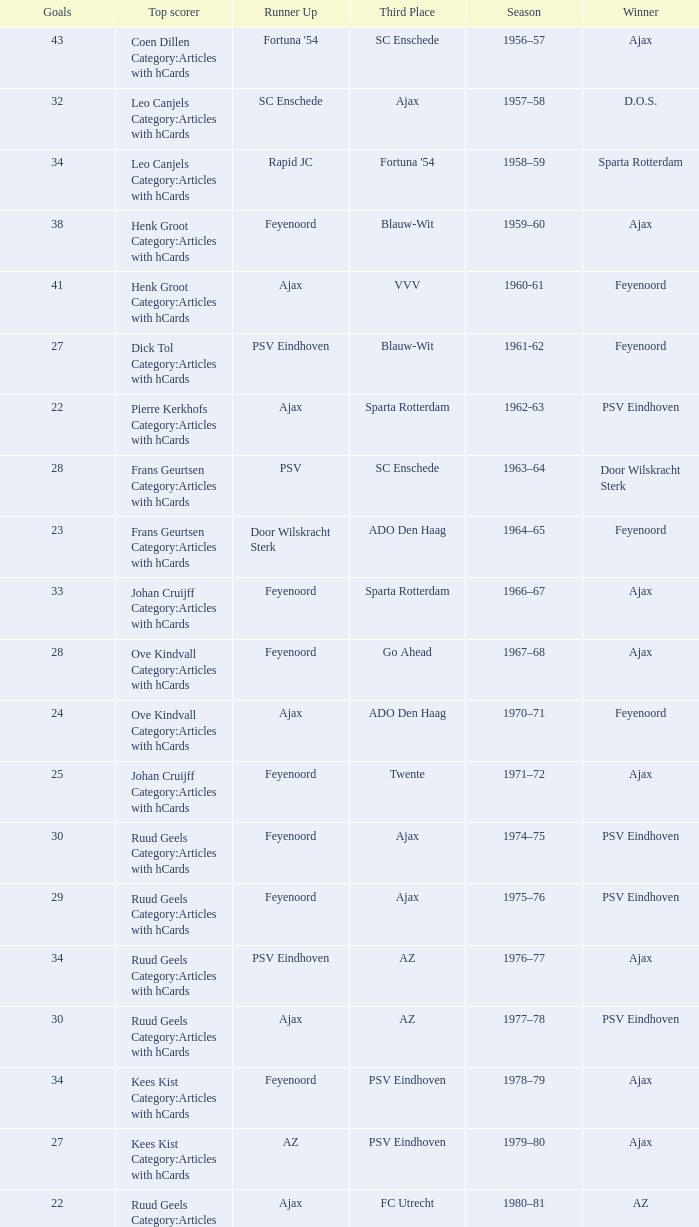When nac breda came in third place and psv eindhoven was the winner who is the top scorer? Klaas-Jan Huntelaar Category:Articles with hCards. 